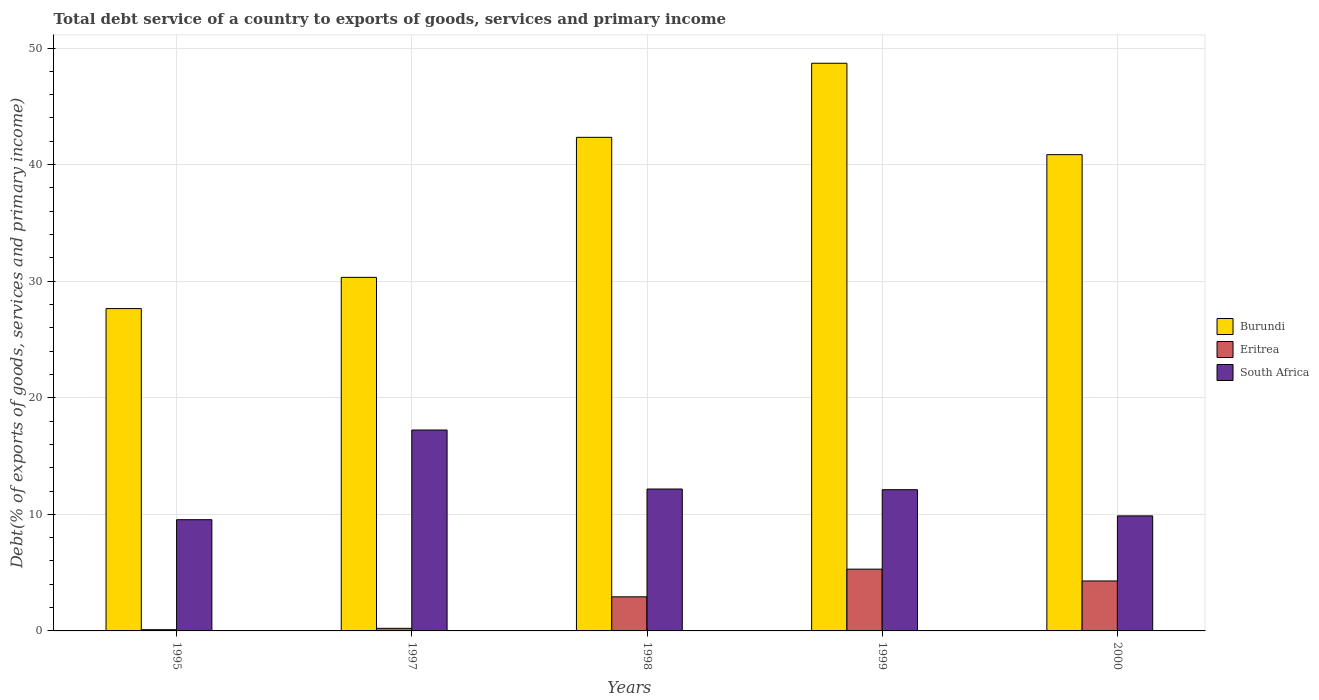How many different coloured bars are there?
Ensure brevity in your answer.  3. How many groups of bars are there?
Offer a terse response. 5. Are the number of bars per tick equal to the number of legend labels?
Make the answer very short. Yes. How many bars are there on the 3rd tick from the left?
Your answer should be very brief. 3. How many bars are there on the 5th tick from the right?
Keep it short and to the point. 3. In how many cases, is the number of bars for a given year not equal to the number of legend labels?
Provide a short and direct response. 0. What is the total debt service in Eritrea in 1999?
Keep it short and to the point. 5.3. Across all years, what is the maximum total debt service in Burundi?
Make the answer very short. 48.69. Across all years, what is the minimum total debt service in South Africa?
Keep it short and to the point. 9.54. In which year was the total debt service in Burundi maximum?
Your answer should be very brief. 1999. What is the total total debt service in South Africa in the graph?
Your answer should be compact. 60.93. What is the difference between the total debt service in South Africa in 1995 and that in 2000?
Provide a succinct answer. -0.33. What is the difference between the total debt service in Burundi in 2000 and the total debt service in South Africa in 1998?
Give a very brief answer. 28.68. What is the average total debt service in South Africa per year?
Offer a very short reply. 12.19. In the year 1998, what is the difference between the total debt service in Eritrea and total debt service in Burundi?
Your answer should be very brief. -39.41. In how many years, is the total debt service in Burundi greater than 24 %?
Provide a succinct answer. 5. What is the ratio of the total debt service in South Africa in 1997 to that in 1999?
Offer a terse response. 1.42. Is the total debt service in South Africa in 1999 less than that in 2000?
Your answer should be very brief. No. What is the difference between the highest and the second highest total debt service in Burundi?
Offer a terse response. 6.35. What is the difference between the highest and the lowest total debt service in South Africa?
Make the answer very short. 7.69. What does the 2nd bar from the left in 1995 represents?
Provide a succinct answer. Eritrea. What does the 3rd bar from the right in 1995 represents?
Your answer should be very brief. Burundi. Is it the case that in every year, the sum of the total debt service in South Africa and total debt service in Eritrea is greater than the total debt service in Burundi?
Give a very brief answer. No. How many bars are there?
Provide a succinct answer. 15. Are all the bars in the graph horizontal?
Provide a succinct answer. No. How many years are there in the graph?
Offer a very short reply. 5. What is the difference between two consecutive major ticks on the Y-axis?
Give a very brief answer. 10. Are the values on the major ticks of Y-axis written in scientific E-notation?
Your response must be concise. No. Does the graph contain any zero values?
Keep it short and to the point. No. What is the title of the graph?
Offer a very short reply. Total debt service of a country to exports of goods, services and primary income. Does "Bahrain" appear as one of the legend labels in the graph?
Ensure brevity in your answer.  No. What is the label or title of the X-axis?
Provide a short and direct response. Years. What is the label or title of the Y-axis?
Your response must be concise. Debt(% of exports of goods, services and primary income). What is the Debt(% of exports of goods, services and primary income) of Burundi in 1995?
Ensure brevity in your answer.  27.65. What is the Debt(% of exports of goods, services and primary income) in Eritrea in 1995?
Offer a very short reply. 0.11. What is the Debt(% of exports of goods, services and primary income) in South Africa in 1995?
Keep it short and to the point. 9.54. What is the Debt(% of exports of goods, services and primary income) of Burundi in 1997?
Your response must be concise. 30.33. What is the Debt(% of exports of goods, services and primary income) of Eritrea in 1997?
Offer a very short reply. 0.22. What is the Debt(% of exports of goods, services and primary income) of South Africa in 1997?
Your response must be concise. 17.23. What is the Debt(% of exports of goods, services and primary income) of Burundi in 1998?
Your answer should be very brief. 42.34. What is the Debt(% of exports of goods, services and primary income) in Eritrea in 1998?
Give a very brief answer. 2.92. What is the Debt(% of exports of goods, services and primary income) in South Africa in 1998?
Offer a terse response. 12.17. What is the Debt(% of exports of goods, services and primary income) in Burundi in 1999?
Make the answer very short. 48.69. What is the Debt(% of exports of goods, services and primary income) of Eritrea in 1999?
Keep it short and to the point. 5.3. What is the Debt(% of exports of goods, services and primary income) in South Africa in 1999?
Your answer should be compact. 12.11. What is the Debt(% of exports of goods, services and primary income) of Burundi in 2000?
Provide a succinct answer. 40.86. What is the Debt(% of exports of goods, services and primary income) of Eritrea in 2000?
Your response must be concise. 4.29. What is the Debt(% of exports of goods, services and primary income) in South Africa in 2000?
Ensure brevity in your answer.  9.87. Across all years, what is the maximum Debt(% of exports of goods, services and primary income) in Burundi?
Your response must be concise. 48.69. Across all years, what is the maximum Debt(% of exports of goods, services and primary income) in Eritrea?
Your answer should be compact. 5.3. Across all years, what is the maximum Debt(% of exports of goods, services and primary income) of South Africa?
Provide a succinct answer. 17.23. Across all years, what is the minimum Debt(% of exports of goods, services and primary income) in Burundi?
Provide a succinct answer. 27.65. Across all years, what is the minimum Debt(% of exports of goods, services and primary income) in Eritrea?
Offer a terse response. 0.11. Across all years, what is the minimum Debt(% of exports of goods, services and primary income) of South Africa?
Your answer should be very brief. 9.54. What is the total Debt(% of exports of goods, services and primary income) of Burundi in the graph?
Ensure brevity in your answer.  189.87. What is the total Debt(% of exports of goods, services and primary income) in Eritrea in the graph?
Your answer should be very brief. 12.84. What is the total Debt(% of exports of goods, services and primary income) of South Africa in the graph?
Provide a short and direct response. 60.93. What is the difference between the Debt(% of exports of goods, services and primary income) of Burundi in 1995 and that in 1997?
Your answer should be compact. -2.68. What is the difference between the Debt(% of exports of goods, services and primary income) in Eritrea in 1995 and that in 1997?
Your answer should be very brief. -0.12. What is the difference between the Debt(% of exports of goods, services and primary income) of South Africa in 1995 and that in 1997?
Provide a short and direct response. -7.69. What is the difference between the Debt(% of exports of goods, services and primary income) in Burundi in 1995 and that in 1998?
Provide a short and direct response. -14.69. What is the difference between the Debt(% of exports of goods, services and primary income) of Eritrea in 1995 and that in 1998?
Provide a short and direct response. -2.82. What is the difference between the Debt(% of exports of goods, services and primary income) of South Africa in 1995 and that in 1998?
Ensure brevity in your answer.  -2.63. What is the difference between the Debt(% of exports of goods, services and primary income) in Burundi in 1995 and that in 1999?
Keep it short and to the point. -21.04. What is the difference between the Debt(% of exports of goods, services and primary income) of Eritrea in 1995 and that in 1999?
Make the answer very short. -5.19. What is the difference between the Debt(% of exports of goods, services and primary income) in South Africa in 1995 and that in 1999?
Your answer should be very brief. -2.57. What is the difference between the Debt(% of exports of goods, services and primary income) of Burundi in 1995 and that in 2000?
Your answer should be compact. -13.21. What is the difference between the Debt(% of exports of goods, services and primary income) of Eritrea in 1995 and that in 2000?
Offer a very short reply. -4.18. What is the difference between the Debt(% of exports of goods, services and primary income) of South Africa in 1995 and that in 2000?
Ensure brevity in your answer.  -0.33. What is the difference between the Debt(% of exports of goods, services and primary income) in Burundi in 1997 and that in 1998?
Give a very brief answer. -12.01. What is the difference between the Debt(% of exports of goods, services and primary income) of Eritrea in 1997 and that in 1998?
Give a very brief answer. -2.7. What is the difference between the Debt(% of exports of goods, services and primary income) of South Africa in 1997 and that in 1998?
Give a very brief answer. 5.06. What is the difference between the Debt(% of exports of goods, services and primary income) in Burundi in 1997 and that in 1999?
Give a very brief answer. -18.37. What is the difference between the Debt(% of exports of goods, services and primary income) in Eritrea in 1997 and that in 1999?
Provide a succinct answer. -5.08. What is the difference between the Debt(% of exports of goods, services and primary income) in South Africa in 1997 and that in 1999?
Offer a very short reply. 5.12. What is the difference between the Debt(% of exports of goods, services and primary income) in Burundi in 1997 and that in 2000?
Your response must be concise. -10.53. What is the difference between the Debt(% of exports of goods, services and primary income) in Eritrea in 1997 and that in 2000?
Make the answer very short. -4.06. What is the difference between the Debt(% of exports of goods, services and primary income) of South Africa in 1997 and that in 2000?
Make the answer very short. 7.36. What is the difference between the Debt(% of exports of goods, services and primary income) of Burundi in 1998 and that in 1999?
Your response must be concise. -6.35. What is the difference between the Debt(% of exports of goods, services and primary income) in Eritrea in 1998 and that in 1999?
Provide a succinct answer. -2.37. What is the difference between the Debt(% of exports of goods, services and primary income) in South Africa in 1998 and that in 1999?
Give a very brief answer. 0.06. What is the difference between the Debt(% of exports of goods, services and primary income) of Burundi in 1998 and that in 2000?
Your answer should be very brief. 1.48. What is the difference between the Debt(% of exports of goods, services and primary income) in Eritrea in 1998 and that in 2000?
Your answer should be compact. -1.36. What is the difference between the Debt(% of exports of goods, services and primary income) of South Africa in 1998 and that in 2000?
Offer a very short reply. 2.3. What is the difference between the Debt(% of exports of goods, services and primary income) in Burundi in 1999 and that in 2000?
Your response must be concise. 7.84. What is the difference between the Debt(% of exports of goods, services and primary income) in Eritrea in 1999 and that in 2000?
Provide a short and direct response. 1.01. What is the difference between the Debt(% of exports of goods, services and primary income) in South Africa in 1999 and that in 2000?
Keep it short and to the point. 2.25. What is the difference between the Debt(% of exports of goods, services and primary income) in Burundi in 1995 and the Debt(% of exports of goods, services and primary income) in Eritrea in 1997?
Provide a succinct answer. 27.43. What is the difference between the Debt(% of exports of goods, services and primary income) in Burundi in 1995 and the Debt(% of exports of goods, services and primary income) in South Africa in 1997?
Your response must be concise. 10.42. What is the difference between the Debt(% of exports of goods, services and primary income) in Eritrea in 1995 and the Debt(% of exports of goods, services and primary income) in South Africa in 1997?
Keep it short and to the point. -17.13. What is the difference between the Debt(% of exports of goods, services and primary income) of Burundi in 1995 and the Debt(% of exports of goods, services and primary income) of Eritrea in 1998?
Your response must be concise. 24.72. What is the difference between the Debt(% of exports of goods, services and primary income) in Burundi in 1995 and the Debt(% of exports of goods, services and primary income) in South Africa in 1998?
Your answer should be very brief. 15.48. What is the difference between the Debt(% of exports of goods, services and primary income) of Eritrea in 1995 and the Debt(% of exports of goods, services and primary income) of South Africa in 1998?
Your answer should be very brief. -12.07. What is the difference between the Debt(% of exports of goods, services and primary income) of Burundi in 1995 and the Debt(% of exports of goods, services and primary income) of Eritrea in 1999?
Ensure brevity in your answer.  22.35. What is the difference between the Debt(% of exports of goods, services and primary income) of Burundi in 1995 and the Debt(% of exports of goods, services and primary income) of South Africa in 1999?
Provide a succinct answer. 15.54. What is the difference between the Debt(% of exports of goods, services and primary income) in Eritrea in 1995 and the Debt(% of exports of goods, services and primary income) in South Africa in 1999?
Give a very brief answer. -12.01. What is the difference between the Debt(% of exports of goods, services and primary income) in Burundi in 1995 and the Debt(% of exports of goods, services and primary income) in Eritrea in 2000?
Keep it short and to the point. 23.36. What is the difference between the Debt(% of exports of goods, services and primary income) of Burundi in 1995 and the Debt(% of exports of goods, services and primary income) of South Africa in 2000?
Give a very brief answer. 17.78. What is the difference between the Debt(% of exports of goods, services and primary income) in Eritrea in 1995 and the Debt(% of exports of goods, services and primary income) in South Africa in 2000?
Give a very brief answer. -9.76. What is the difference between the Debt(% of exports of goods, services and primary income) in Burundi in 1997 and the Debt(% of exports of goods, services and primary income) in Eritrea in 1998?
Your answer should be very brief. 27.4. What is the difference between the Debt(% of exports of goods, services and primary income) in Burundi in 1997 and the Debt(% of exports of goods, services and primary income) in South Africa in 1998?
Offer a very short reply. 18.16. What is the difference between the Debt(% of exports of goods, services and primary income) in Eritrea in 1997 and the Debt(% of exports of goods, services and primary income) in South Africa in 1998?
Keep it short and to the point. -11.95. What is the difference between the Debt(% of exports of goods, services and primary income) of Burundi in 1997 and the Debt(% of exports of goods, services and primary income) of Eritrea in 1999?
Keep it short and to the point. 25.03. What is the difference between the Debt(% of exports of goods, services and primary income) in Burundi in 1997 and the Debt(% of exports of goods, services and primary income) in South Africa in 1999?
Provide a short and direct response. 18.21. What is the difference between the Debt(% of exports of goods, services and primary income) in Eritrea in 1997 and the Debt(% of exports of goods, services and primary income) in South Africa in 1999?
Make the answer very short. -11.89. What is the difference between the Debt(% of exports of goods, services and primary income) in Burundi in 1997 and the Debt(% of exports of goods, services and primary income) in Eritrea in 2000?
Your response must be concise. 26.04. What is the difference between the Debt(% of exports of goods, services and primary income) of Burundi in 1997 and the Debt(% of exports of goods, services and primary income) of South Africa in 2000?
Your answer should be compact. 20.46. What is the difference between the Debt(% of exports of goods, services and primary income) in Eritrea in 1997 and the Debt(% of exports of goods, services and primary income) in South Africa in 2000?
Offer a terse response. -9.65. What is the difference between the Debt(% of exports of goods, services and primary income) in Burundi in 1998 and the Debt(% of exports of goods, services and primary income) in Eritrea in 1999?
Your answer should be compact. 37.04. What is the difference between the Debt(% of exports of goods, services and primary income) of Burundi in 1998 and the Debt(% of exports of goods, services and primary income) of South Africa in 1999?
Your answer should be very brief. 30.22. What is the difference between the Debt(% of exports of goods, services and primary income) of Eritrea in 1998 and the Debt(% of exports of goods, services and primary income) of South Africa in 1999?
Offer a very short reply. -9.19. What is the difference between the Debt(% of exports of goods, services and primary income) in Burundi in 1998 and the Debt(% of exports of goods, services and primary income) in Eritrea in 2000?
Your answer should be compact. 38.05. What is the difference between the Debt(% of exports of goods, services and primary income) of Burundi in 1998 and the Debt(% of exports of goods, services and primary income) of South Africa in 2000?
Your response must be concise. 32.47. What is the difference between the Debt(% of exports of goods, services and primary income) in Eritrea in 1998 and the Debt(% of exports of goods, services and primary income) in South Africa in 2000?
Give a very brief answer. -6.94. What is the difference between the Debt(% of exports of goods, services and primary income) of Burundi in 1999 and the Debt(% of exports of goods, services and primary income) of Eritrea in 2000?
Offer a very short reply. 44.41. What is the difference between the Debt(% of exports of goods, services and primary income) of Burundi in 1999 and the Debt(% of exports of goods, services and primary income) of South Africa in 2000?
Keep it short and to the point. 38.83. What is the difference between the Debt(% of exports of goods, services and primary income) in Eritrea in 1999 and the Debt(% of exports of goods, services and primary income) in South Africa in 2000?
Your answer should be very brief. -4.57. What is the average Debt(% of exports of goods, services and primary income) in Burundi per year?
Your answer should be compact. 37.97. What is the average Debt(% of exports of goods, services and primary income) in Eritrea per year?
Keep it short and to the point. 2.57. What is the average Debt(% of exports of goods, services and primary income) of South Africa per year?
Offer a very short reply. 12.19. In the year 1995, what is the difference between the Debt(% of exports of goods, services and primary income) in Burundi and Debt(% of exports of goods, services and primary income) in Eritrea?
Offer a terse response. 27.54. In the year 1995, what is the difference between the Debt(% of exports of goods, services and primary income) in Burundi and Debt(% of exports of goods, services and primary income) in South Africa?
Ensure brevity in your answer.  18.11. In the year 1995, what is the difference between the Debt(% of exports of goods, services and primary income) of Eritrea and Debt(% of exports of goods, services and primary income) of South Africa?
Provide a succinct answer. -9.44. In the year 1997, what is the difference between the Debt(% of exports of goods, services and primary income) in Burundi and Debt(% of exports of goods, services and primary income) in Eritrea?
Your response must be concise. 30.11. In the year 1997, what is the difference between the Debt(% of exports of goods, services and primary income) in Burundi and Debt(% of exports of goods, services and primary income) in South Africa?
Offer a very short reply. 13.1. In the year 1997, what is the difference between the Debt(% of exports of goods, services and primary income) in Eritrea and Debt(% of exports of goods, services and primary income) in South Africa?
Give a very brief answer. -17.01. In the year 1998, what is the difference between the Debt(% of exports of goods, services and primary income) in Burundi and Debt(% of exports of goods, services and primary income) in Eritrea?
Offer a very short reply. 39.41. In the year 1998, what is the difference between the Debt(% of exports of goods, services and primary income) in Burundi and Debt(% of exports of goods, services and primary income) in South Africa?
Provide a succinct answer. 30.17. In the year 1998, what is the difference between the Debt(% of exports of goods, services and primary income) in Eritrea and Debt(% of exports of goods, services and primary income) in South Africa?
Offer a terse response. -9.25. In the year 1999, what is the difference between the Debt(% of exports of goods, services and primary income) of Burundi and Debt(% of exports of goods, services and primary income) of Eritrea?
Your answer should be very brief. 43.4. In the year 1999, what is the difference between the Debt(% of exports of goods, services and primary income) of Burundi and Debt(% of exports of goods, services and primary income) of South Africa?
Your answer should be very brief. 36.58. In the year 1999, what is the difference between the Debt(% of exports of goods, services and primary income) in Eritrea and Debt(% of exports of goods, services and primary income) in South Africa?
Keep it short and to the point. -6.82. In the year 2000, what is the difference between the Debt(% of exports of goods, services and primary income) in Burundi and Debt(% of exports of goods, services and primary income) in Eritrea?
Offer a very short reply. 36.57. In the year 2000, what is the difference between the Debt(% of exports of goods, services and primary income) of Burundi and Debt(% of exports of goods, services and primary income) of South Africa?
Your answer should be very brief. 30.99. In the year 2000, what is the difference between the Debt(% of exports of goods, services and primary income) in Eritrea and Debt(% of exports of goods, services and primary income) in South Africa?
Provide a succinct answer. -5.58. What is the ratio of the Debt(% of exports of goods, services and primary income) in Burundi in 1995 to that in 1997?
Offer a very short reply. 0.91. What is the ratio of the Debt(% of exports of goods, services and primary income) of Eritrea in 1995 to that in 1997?
Offer a terse response. 0.47. What is the ratio of the Debt(% of exports of goods, services and primary income) in South Africa in 1995 to that in 1997?
Offer a terse response. 0.55. What is the ratio of the Debt(% of exports of goods, services and primary income) in Burundi in 1995 to that in 1998?
Offer a very short reply. 0.65. What is the ratio of the Debt(% of exports of goods, services and primary income) in Eritrea in 1995 to that in 1998?
Your response must be concise. 0.04. What is the ratio of the Debt(% of exports of goods, services and primary income) in South Africa in 1995 to that in 1998?
Your answer should be compact. 0.78. What is the ratio of the Debt(% of exports of goods, services and primary income) of Burundi in 1995 to that in 1999?
Give a very brief answer. 0.57. What is the ratio of the Debt(% of exports of goods, services and primary income) in Eritrea in 1995 to that in 1999?
Ensure brevity in your answer.  0.02. What is the ratio of the Debt(% of exports of goods, services and primary income) in South Africa in 1995 to that in 1999?
Your answer should be compact. 0.79. What is the ratio of the Debt(% of exports of goods, services and primary income) of Burundi in 1995 to that in 2000?
Make the answer very short. 0.68. What is the ratio of the Debt(% of exports of goods, services and primary income) of Eritrea in 1995 to that in 2000?
Make the answer very short. 0.02. What is the ratio of the Debt(% of exports of goods, services and primary income) in South Africa in 1995 to that in 2000?
Make the answer very short. 0.97. What is the ratio of the Debt(% of exports of goods, services and primary income) in Burundi in 1997 to that in 1998?
Your answer should be very brief. 0.72. What is the ratio of the Debt(% of exports of goods, services and primary income) of Eritrea in 1997 to that in 1998?
Make the answer very short. 0.08. What is the ratio of the Debt(% of exports of goods, services and primary income) of South Africa in 1997 to that in 1998?
Your answer should be very brief. 1.42. What is the ratio of the Debt(% of exports of goods, services and primary income) in Burundi in 1997 to that in 1999?
Provide a succinct answer. 0.62. What is the ratio of the Debt(% of exports of goods, services and primary income) of Eritrea in 1997 to that in 1999?
Your response must be concise. 0.04. What is the ratio of the Debt(% of exports of goods, services and primary income) of South Africa in 1997 to that in 1999?
Your answer should be compact. 1.42. What is the ratio of the Debt(% of exports of goods, services and primary income) of Burundi in 1997 to that in 2000?
Provide a succinct answer. 0.74. What is the ratio of the Debt(% of exports of goods, services and primary income) of Eritrea in 1997 to that in 2000?
Give a very brief answer. 0.05. What is the ratio of the Debt(% of exports of goods, services and primary income) of South Africa in 1997 to that in 2000?
Keep it short and to the point. 1.75. What is the ratio of the Debt(% of exports of goods, services and primary income) of Burundi in 1998 to that in 1999?
Ensure brevity in your answer.  0.87. What is the ratio of the Debt(% of exports of goods, services and primary income) in Eritrea in 1998 to that in 1999?
Your answer should be compact. 0.55. What is the ratio of the Debt(% of exports of goods, services and primary income) of South Africa in 1998 to that in 1999?
Provide a succinct answer. 1. What is the ratio of the Debt(% of exports of goods, services and primary income) in Burundi in 1998 to that in 2000?
Provide a short and direct response. 1.04. What is the ratio of the Debt(% of exports of goods, services and primary income) in Eritrea in 1998 to that in 2000?
Ensure brevity in your answer.  0.68. What is the ratio of the Debt(% of exports of goods, services and primary income) of South Africa in 1998 to that in 2000?
Offer a terse response. 1.23. What is the ratio of the Debt(% of exports of goods, services and primary income) of Burundi in 1999 to that in 2000?
Your answer should be compact. 1.19. What is the ratio of the Debt(% of exports of goods, services and primary income) in Eritrea in 1999 to that in 2000?
Give a very brief answer. 1.24. What is the ratio of the Debt(% of exports of goods, services and primary income) in South Africa in 1999 to that in 2000?
Provide a succinct answer. 1.23. What is the difference between the highest and the second highest Debt(% of exports of goods, services and primary income) of Burundi?
Offer a terse response. 6.35. What is the difference between the highest and the second highest Debt(% of exports of goods, services and primary income) of Eritrea?
Offer a terse response. 1.01. What is the difference between the highest and the second highest Debt(% of exports of goods, services and primary income) in South Africa?
Give a very brief answer. 5.06. What is the difference between the highest and the lowest Debt(% of exports of goods, services and primary income) in Burundi?
Provide a short and direct response. 21.04. What is the difference between the highest and the lowest Debt(% of exports of goods, services and primary income) in Eritrea?
Your answer should be compact. 5.19. What is the difference between the highest and the lowest Debt(% of exports of goods, services and primary income) in South Africa?
Your answer should be very brief. 7.69. 